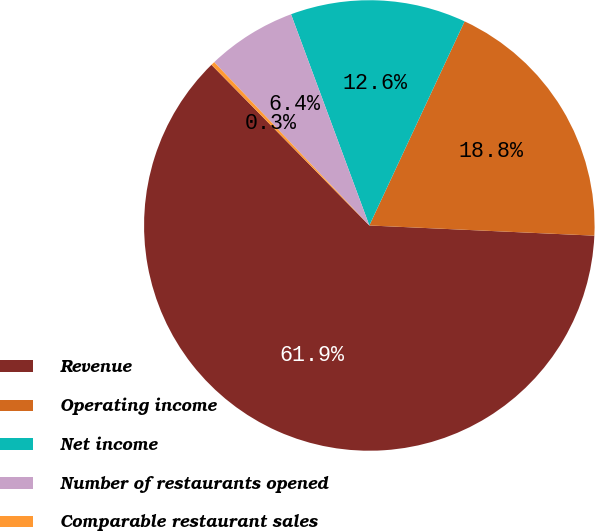Convert chart. <chart><loc_0><loc_0><loc_500><loc_500><pie_chart><fcel>Revenue<fcel>Operating income<fcel>Net income<fcel>Number of restaurants opened<fcel>Comparable restaurant sales<nl><fcel>61.92%<fcel>18.77%<fcel>12.6%<fcel>6.44%<fcel>0.27%<nl></chart> 